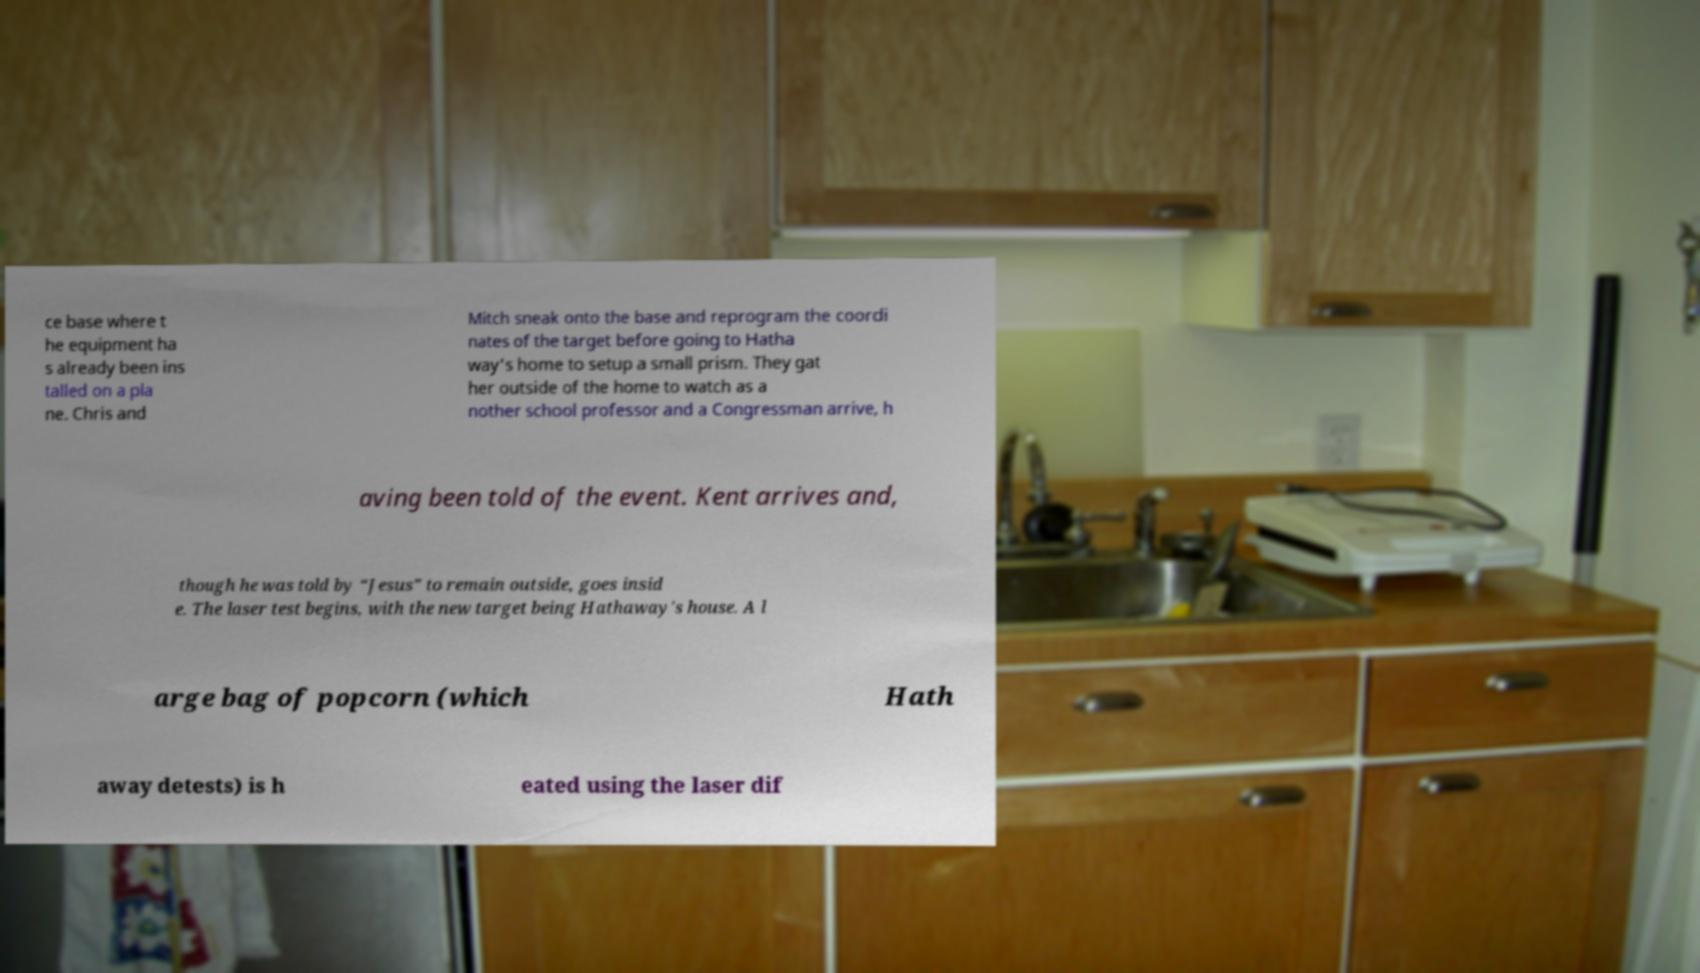Please identify and transcribe the text found in this image. ce base where t he equipment ha s already been ins talled on a pla ne. Chris and Mitch sneak onto the base and reprogram the coordi nates of the target before going to Hatha way's home to setup a small prism. They gat her outside of the home to watch as a nother school professor and a Congressman arrive, h aving been told of the event. Kent arrives and, though he was told by “Jesus” to remain outside, goes insid e. The laser test begins, with the new target being Hathaway's house. A l arge bag of popcorn (which Hath away detests) is h eated using the laser dif 